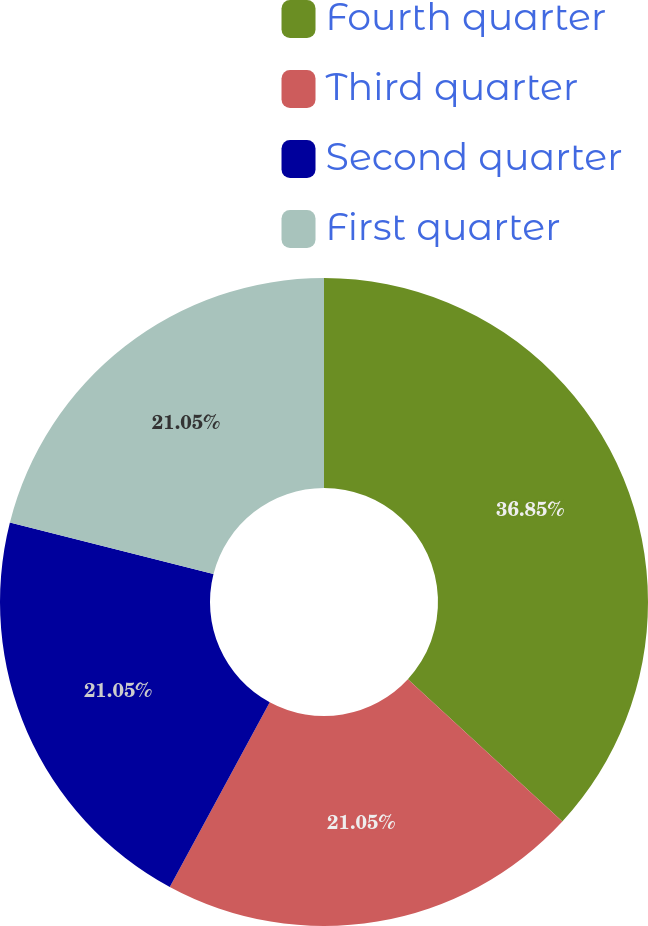<chart> <loc_0><loc_0><loc_500><loc_500><pie_chart><fcel>Fourth quarter<fcel>Third quarter<fcel>Second quarter<fcel>First quarter<nl><fcel>36.84%<fcel>21.05%<fcel>21.05%<fcel>21.05%<nl></chart> 